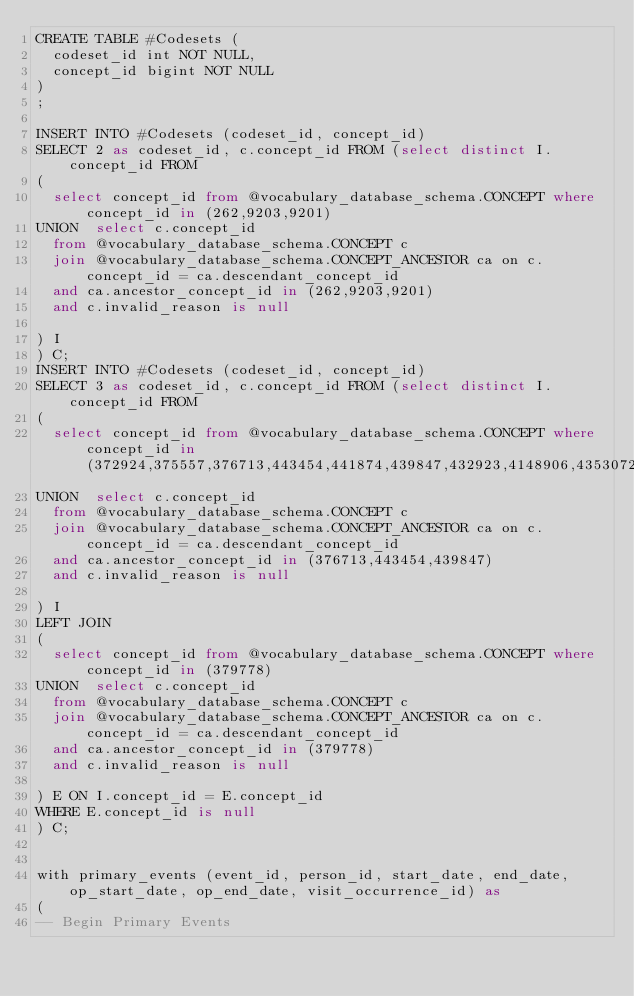Convert code to text. <code><loc_0><loc_0><loc_500><loc_500><_SQL_>CREATE TABLE #Codesets (
  codeset_id int NOT NULL,
  concept_id bigint NOT NULL
)
;

INSERT INTO #Codesets (codeset_id, concept_id)
SELECT 2 as codeset_id, c.concept_id FROM (select distinct I.concept_id FROM
( 
  select concept_id from @vocabulary_database_schema.CONCEPT where concept_id in (262,9203,9201)
UNION  select c.concept_id
  from @vocabulary_database_schema.CONCEPT c
  join @vocabulary_database_schema.CONCEPT_ANCESTOR ca on c.concept_id = ca.descendant_concept_id
  and ca.ancestor_concept_id in (262,9203,9201)
  and c.invalid_reason is null

) I
) C;
INSERT INTO #Codesets (codeset_id, concept_id)
SELECT 3 as codeset_id, c.concept_id FROM (select distinct I.concept_id FROM
( 
  select concept_id from @vocabulary_database_schema.CONCEPT where concept_id in (372924,375557,376713,443454,441874,439847,432923,4148906,43530727,42538062)
UNION  select c.concept_id
  from @vocabulary_database_schema.CONCEPT c
  join @vocabulary_database_schema.CONCEPT_ANCESTOR ca on c.concept_id = ca.descendant_concept_id
  and ca.ancestor_concept_id in (376713,443454,439847)
  and c.invalid_reason is null

) I
LEFT JOIN
(
  select concept_id from @vocabulary_database_schema.CONCEPT where concept_id in (379778)
UNION  select c.concept_id
  from @vocabulary_database_schema.CONCEPT c
  join @vocabulary_database_schema.CONCEPT_ANCESTOR ca on c.concept_id = ca.descendant_concept_id
  and ca.ancestor_concept_id in (379778)
  and c.invalid_reason is null

) E ON I.concept_id = E.concept_id
WHERE E.concept_id is null
) C;


with primary_events (event_id, person_id, start_date, end_date, op_start_date, op_end_date, visit_occurrence_id) as
(
-- Begin Primary Events</code> 